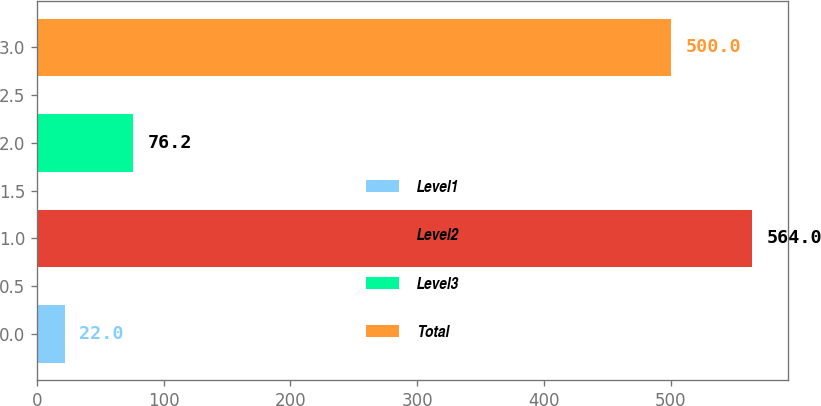Convert chart to OTSL. <chart><loc_0><loc_0><loc_500><loc_500><bar_chart><fcel>Level1<fcel>Level2<fcel>Level3<fcel>Total<nl><fcel>22<fcel>564<fcel>76.2<fcel>500<nl></chart> 